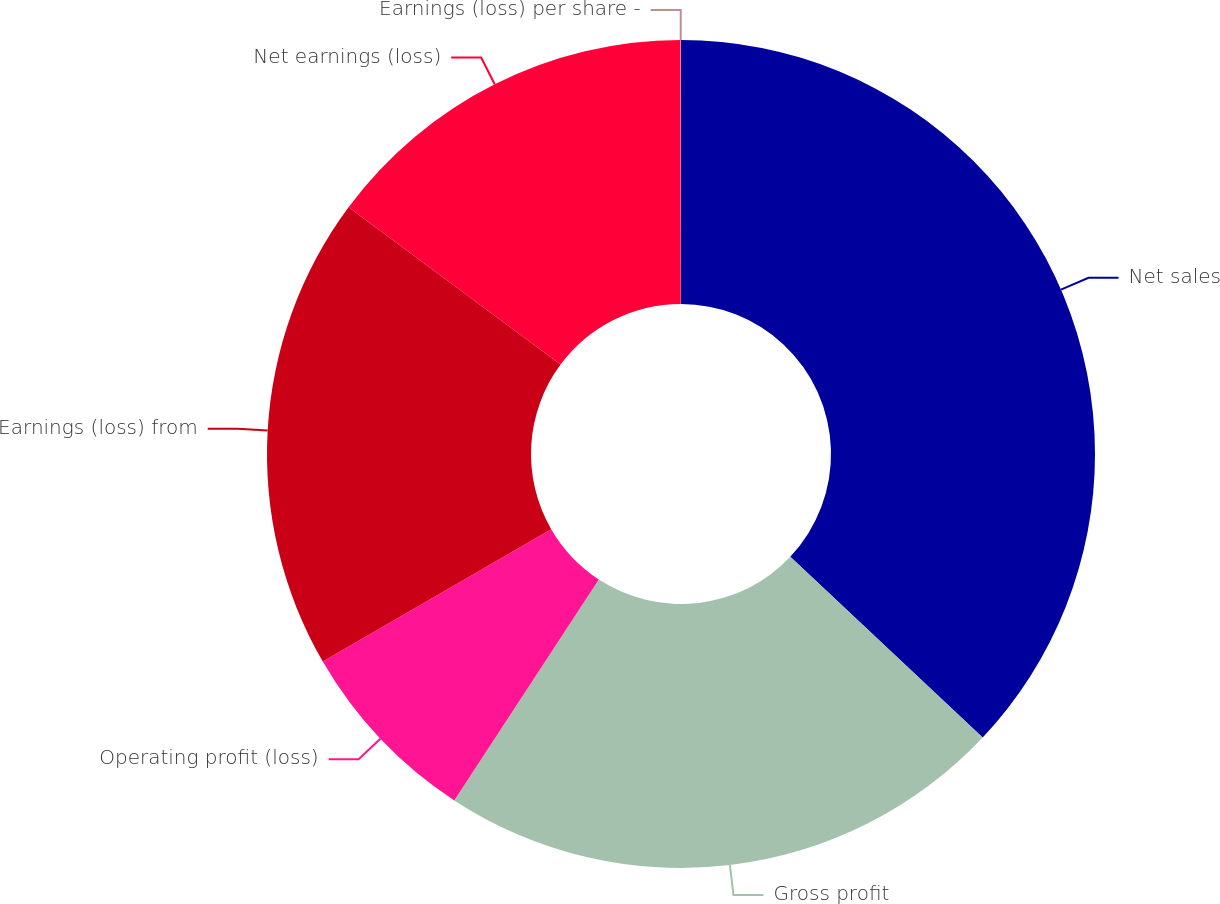Convert chart to OTSL. <chart><loc_0><loc_0><loc_500><loc_500><pie_chart><fcel>Net sales<fcel>Gross profit<fcel>Operating profit (loss)<fcel>Earnings (loss) from<fcel>Net earnings (loss)<fcel>Earnings (loss) per share -<nl><fcel>37.01%<fcel>22.22%<fcel>7.42%<fcel>18.52%<fcel>14.82%<fcel>0.02%<nl></chart> 